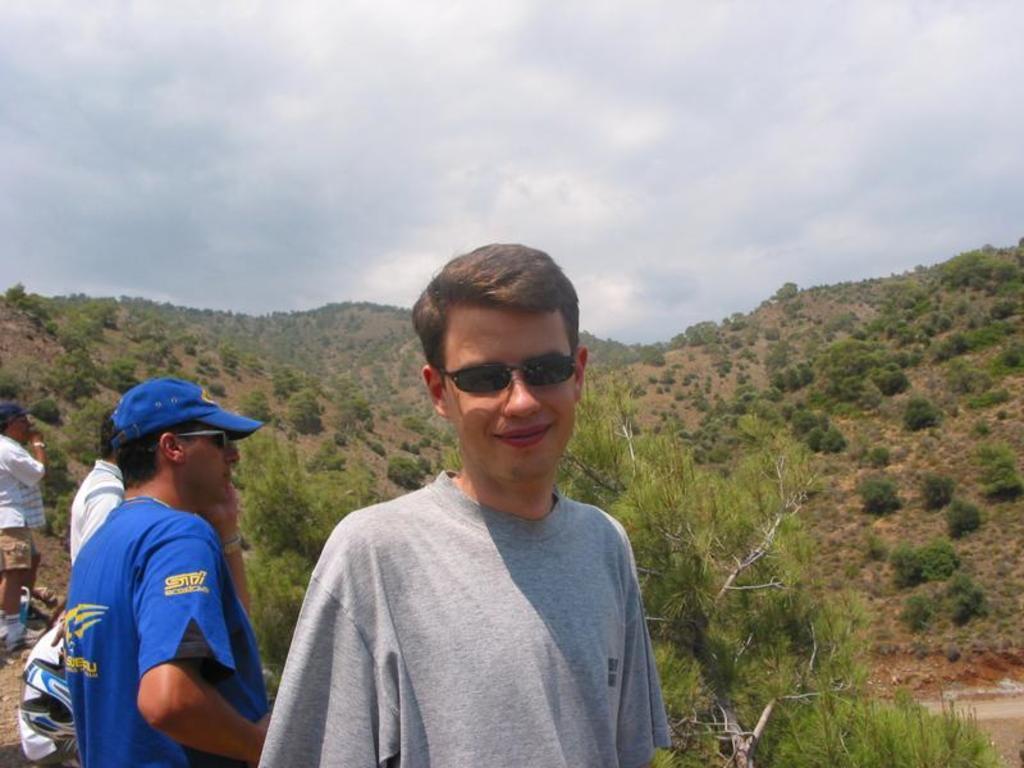Can you describe this image briefly? In this image we can see a group of people standing. On the backside we can see a group of trees on the hill and the sky which looks cloudy. 